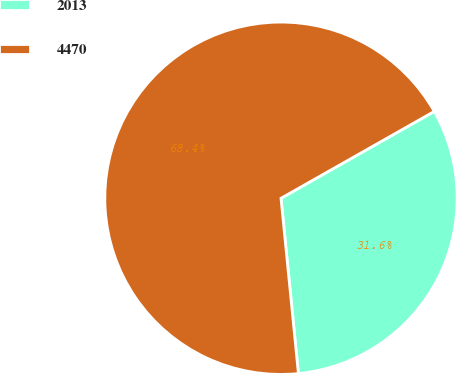Convert chart. <chart><loc_0><loc_0><loc_500><loc_500><pie_chart><fcel>2013<fcel>4470<nl><fcel>31.63%<fcel>68.37%<nl></chart> 